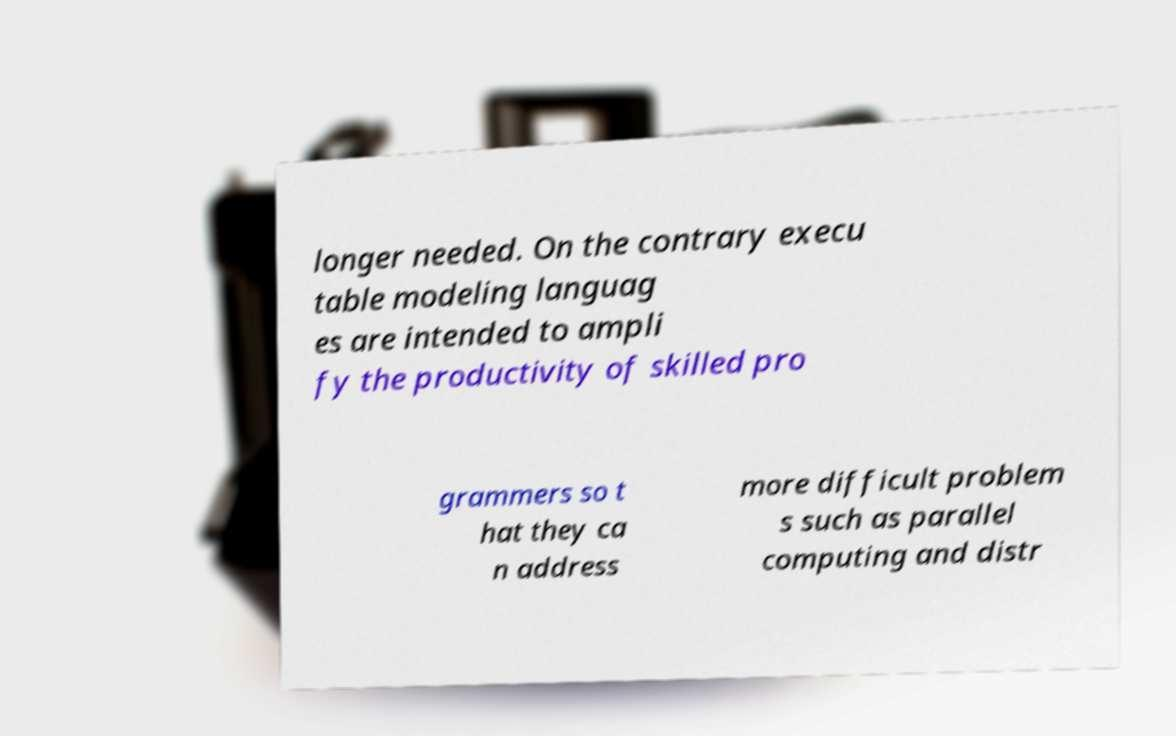Please identify and transcribe the text found in this image. longer needed. On the contrary execu table modeling languag es are intended to ampli fy the productivity of skilled pro grammers so t hat they ca n address more difficult problem s such as parallel computing and distr 